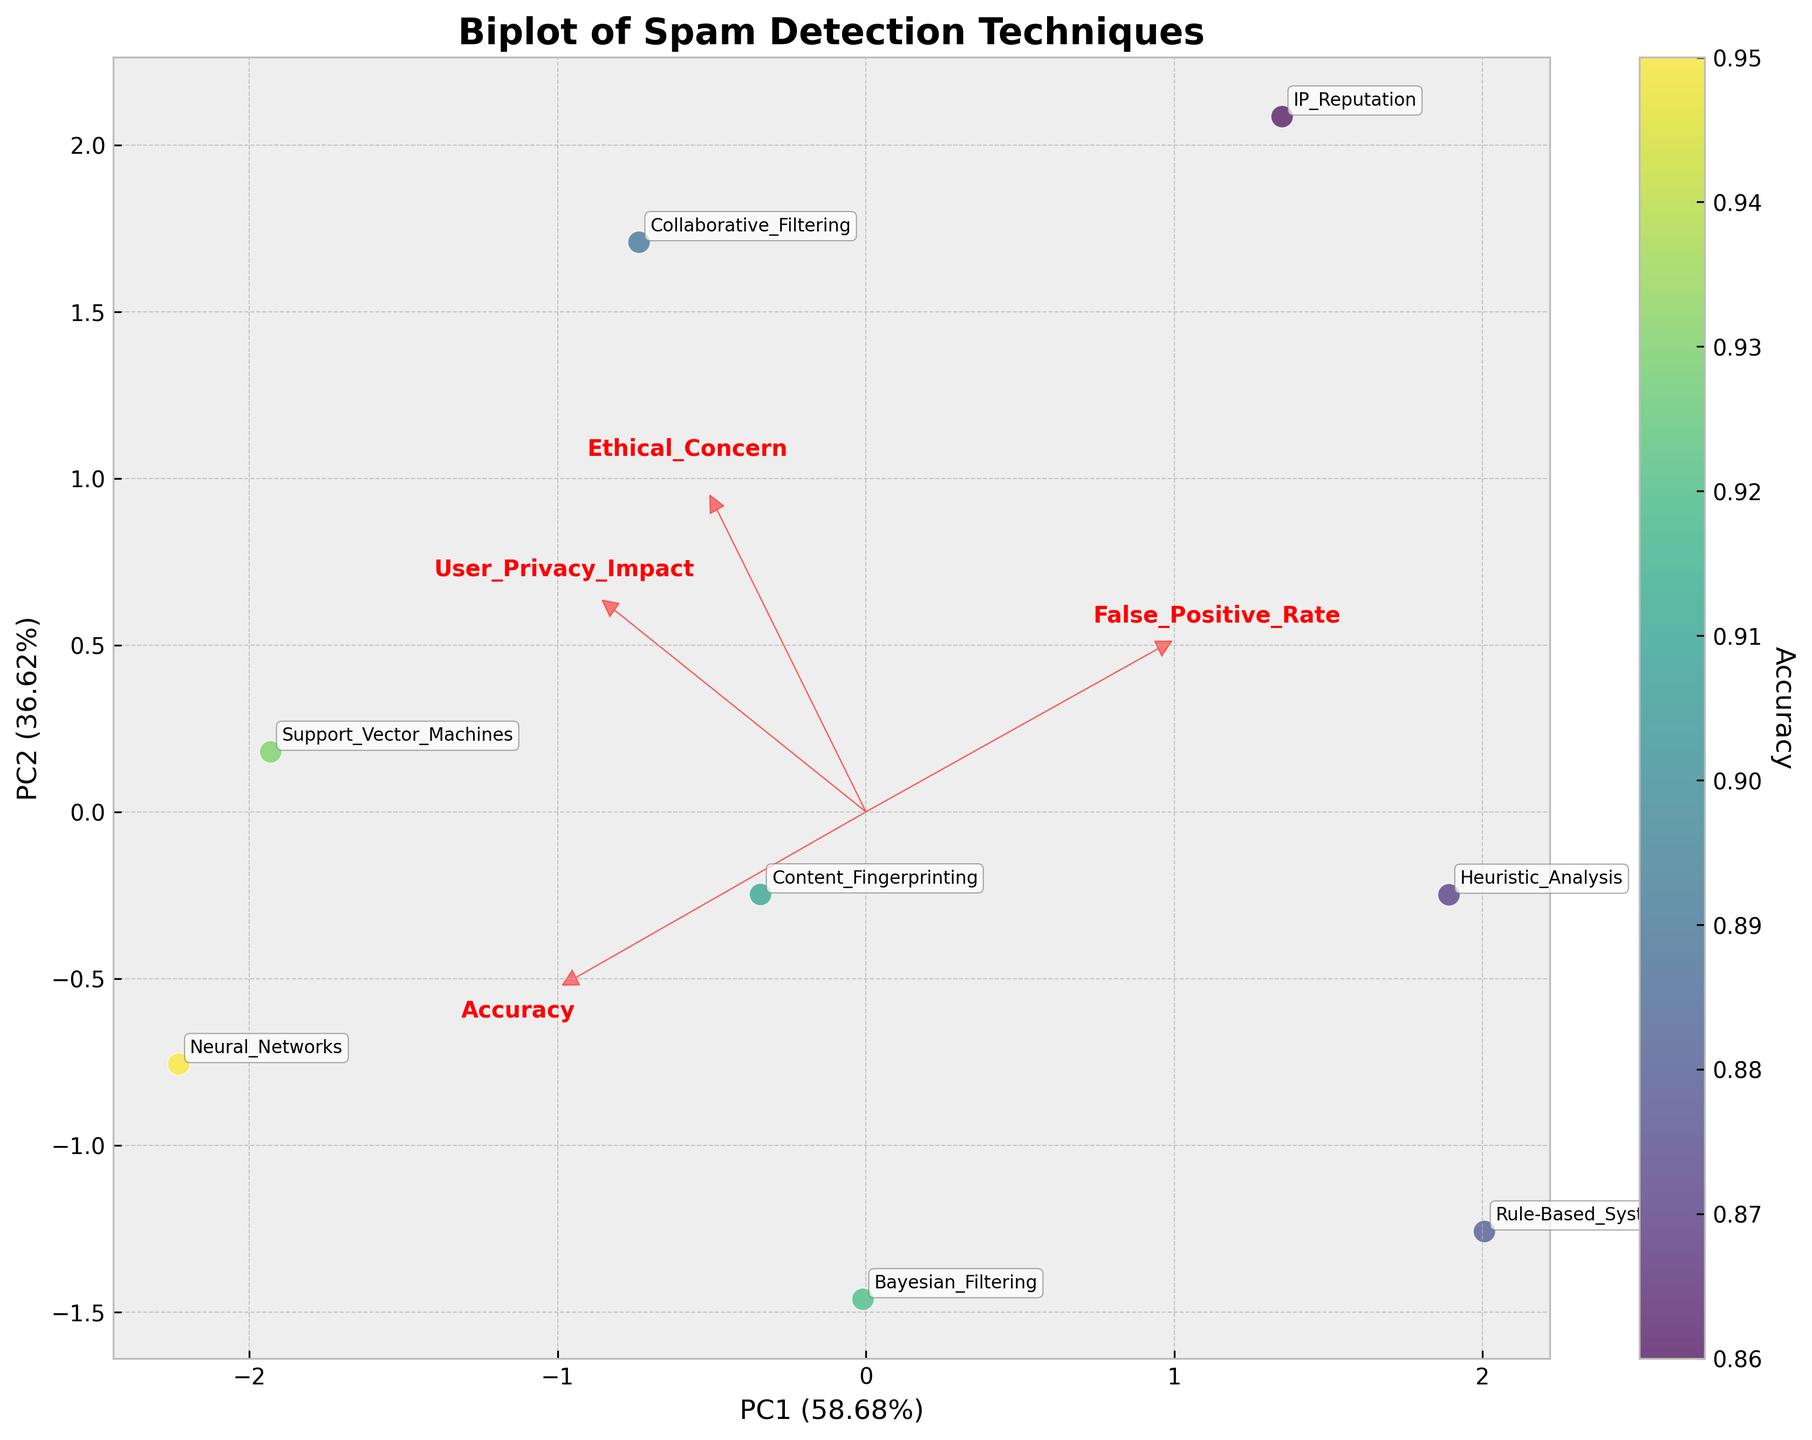What is the title of the figure? The title is located at the top of the figure. It is labeled as "Biplot of Spam Detection Techniques".
Answer: Biplot of Spam Detection Techniques Which spam detection technique has the highest accuracy? The colorbar indicates accuracy with darker colors representing higher values. The technique with the darkest color is Neural_Networks.
Answer: Neural_Networks What are the labels of the axes, and what do they represent? The x-axis is labeled "PC1" and the y-axis is labeled "PC2". These represent the first and second principal components from the PCA analysis.
Answer: PC1 and PC2 Which technique is the closest to the arrow for 'Ethical_Concern'? The arrow representing 'Ethical_Concern' points upwards and slightly to the right. The technique positioned closest to it is IP_Reputation.
Answer: IP_Reputation Which technique has a higher ethical concern: Bayesian_Filtering or Support_Vector_Machines? The 'Ethical_Concern' arrow points to the top-right. Support_Vector_Machines is closer to this arrow, indicating a higher ethical concern compared to Bayesian_Filtering.
Answer: Support_Vector_Machines How many data points represent different spam detection techniques? Each data point on the scatter plot represents a different technique. By counting the annotated points, there are 8 in total.
Answer: 8 Which principal component explains more variance, PC1 or PC2? The variance explained by each principal component is indicated in the axis labels. PC1 has a higher percentage compared to PC2.
Answer: PC1 What is the technique with the highest 'False_Positive_Rate' and how can you identify it? The 'False_Positive_Rate' arrow points downwards. The closest technique to this arrow is IP_Reputation.
Answer: IP_Reputation Which feature has the strongest association with PC1? The length and direction of the arrows represent the strength and association with PCs. The arrow pointing the most along PC1 is 'User_Privacy_Impact'.
Answer: User_Privacy_Impact Is there any technique that has both high accuracy and low ethical concern? Checking techniques closer to 'Accuracy' arrow (right) and away from 'Ethical_Concern' (less upward), Bayesian_Filtering is a suitable candidate.
Answer: Bayesian_Filtering 